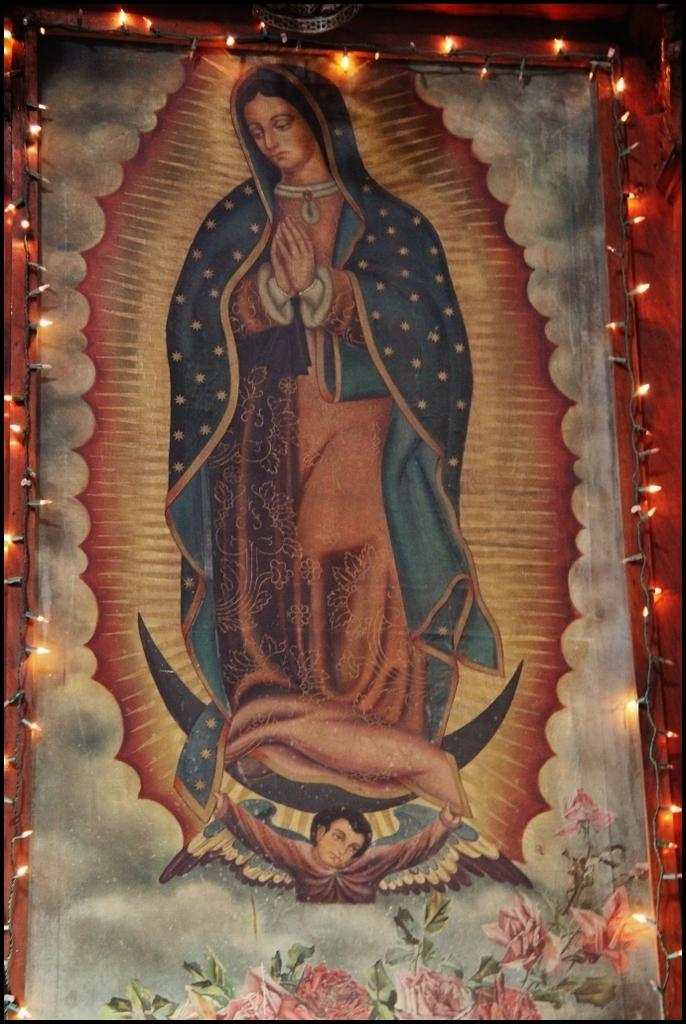What is the main object in the image? There is a frame with lights in the image. What is depicted within the frame? The frame contains a picture of a woman and a boy. What can be seen at the bottom of the image? There are flowers at the bottom of the image. What type of skirt is the woman wearing in the image? There is no skirt visible in the image, as the woman is depicted within a picture frame. How many seats are present in the image? There are no seats present in the image; it features a frame with lights and a picture of a woman and a boy. 